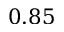Convert formula to latex. <formula><loc_0><loc_0><loc_500><loc_500>0 . 8 5</formula> 